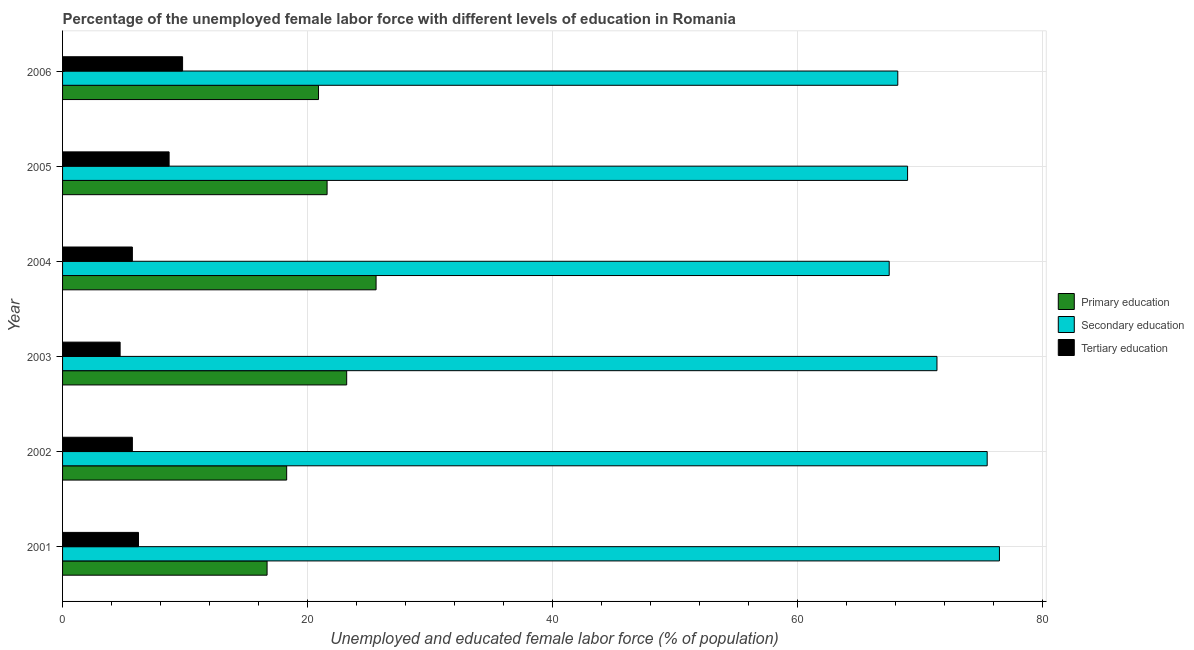How many different coloured bars are there?
Your answer should be compact. 3. How many groups of bars are there?
Your answer should be compact. 6. Are the number of bars per tick equal to the number of legend labels?
Offer a terse response. Yes. Are the number of bars on each tick of the Y-axis equal?
Offer a very short reply. Yes. What is the label of the 2nd group of bars from the top?
Provide a succinct answer. 2005. In how many cases, is the number of bars for a given year not equal to the number of legend labels?
Your response must be concise. 0. What is the percentage of female labor force who received tertiary education in 2005?
Offer a very short reply. 8.7. Across all years, what is the maximum percentage of female labor force who received secondary education?
Your answer should be very brief. 76.5. Across all years, what is the minimum percentage of female labor force who received primary education?
Your answer should be very brief. 16.7. In which year was the percentage of female labor force who received secondary education maximum?
Provide a short and direct response. 2001. What is the total percentage of female labor force who received tertiary education in the graph?
Ensure brevity in your answer.  40.8. What is the difference between the percentage of female labor force who received secondary education in 2002 and that in 2004?
Ensure brevity in your answer.  8. What is the difference between the percentage of female labor force who received primary education in 2004 and the percentage of female labor force who received secondary education in 2006?
Your answer should be very brief. -42.6. What is the average percentage of female labor force who received tertiary education per year?
Ensure brevity in your answer.  6.8. In the year 2002, what is the difference between the percentage of female labor force who received primary education and percentage of female labor force who received secondary education?
Give a very brief answer. -57.2. In how many years, is the percentage of female labor force who received secondary education greater than 16 %?
Keep it short and to the point. 6. What is the ratio of the percentage of female labor force who received secondary education in 2004 to that in 2005?
Provide a short and direct response. 0.98. Is the percentage of female labor force who received primary education in 2002 less than that in 2006?
Provide a succinct answer. Yes. What is the difference between the highest and the lowest percentage of female labor force who received primary education?
Offer a very short reply. 8.9. What does the 1st bar from the top in 2003 represents?
Offer a terse response. Tertiary education. What does the 3rd bar from the bottom in 2004 represents?
Your answer should be compact. Tertiary education. How many years are there in the graph?
Offer a very short reply. 6. Where does the legend appear in the graph?
Ensure brevity in your answer.  Center right. What is the title of the graph?
Offer a terse response. Percentage of the unemployed female labor force with different levels of education in Romania. Does "Negligence towards kids" appear as one of the legend labels in the graph?
Your response must be concise. No. What is the label or title of the X-axis?
Give a very brief answer. Unemployed and educated female labor force (% of population). What is the label or title of the Y-axis?
Your response must be concise. Year. What is the Unemployed and educated female labor force (% of population) in Primary education in 2001?
Provide a short and direct response. 16.7. What is the Unemployed and educated female labor force (% of population) of Secondary education in 2001?
Make the answer very short. 76.5. What is the Unemployed and educated female labor force (% of population) in Tertiary education in 2001?
Provide a short and direct response. 6.2. What is the Unemployed and educated female labor force (% of population) of Primary education in 2002?
Your answer should be compact. 18.3. What is the Unemployed and educated female labor force (% of population) in Secondary education in 2002?
Keep it short and to the point. 75.5. What is the Unemployed and educated female labor force (% of population) of Tertiary education in 2002?
Ensure brevity in your answer.  5.7. What is the Unemployed and educated female labor force (% of population) in Primary education in 2003?
Provide a succinct answer. 23.2. What is the Unemployed and educated female labor force (% of population) in Secondary education in 2003?
Make the answer very short. 71.4. What is the Unemployed and educated female labor force (% of population) of Tertiary education in 2003?
Offer a very short reply. 4.7. What is the Unemployed and educated female labor force (% of population) of Primary education in 2004?
Your response must be concise. 25.6. What is the Unemployed and educated female labor force (% of population) of Secondary education in 2004?
Ensure brevity in your answer.  67.5. What is the Unemployed and educated female labor force (% of population) in Tertiary education in 2004?
Provide a succinct answer. 5.7. What is the Unemployed and educated female labor force (% of population) of Primary education in 2005?
Provide a short and direct response. 21.6. What is the Unemployed and educated female labor force (% of population) of Secondary education in 2005?
Give a very brief answer. 69. What is the Unemployed and educated female labor force (% of population) of Tertiary education in 2005?
Your response must be concise. 8.7. What is the Unemployed and educated female labor force (% of population) in Primary education in 2006?
Provide a short and direct response. 20.9. What is the Unemployed and educated female labor force (% of population) of Secondary education in 2006?
Offer a very short reply. 68.2. What is the Unemployed and educated female labor force (% of population) in Tertiary education in 2006?
Make the answer very short. 9.8. Across all years, what is the maximum Unemployed and educated female labor force (% of population) in Primary education?
Provide a succinct answer. 25.6. Across all years, what is the maximum Unemployed and educated female labor force (% of population) of Secondary education?
Offer a very short reply. 76.5. Across all years, what is the maximum Unemployed and educated female labor force (% of population) of Tertiary education?
Give a very brief answer. 9.8. Across all years, what is the minimum Unemployed and educated female labor force (% of population) in Primary education?
Offer a terse response. 16.7. Across all years, what is the minimum Unemployed and educated female labor force (% of population) of Secondary education?
Provide a succinct answer. 67.5. Across all years, what is the minimum Unemployed and educated female labor force (% of population) in Tertiary education?
Provide a succinct answer. 4.7. What is the total Unemployed and educated female labor force (% of population) of Primary education in the graph?
Keep it short and to the point. 126.3. What is the total Unemployed and educated female labor force (% of population) in Secondary education in the graph?
Offer a very short reply. 428.1. What is the total Unemployed and educated female labor force (% of population) in Tertiary education in the graph?
Offer a terse response. 40.8. What is the difference between the Unemployed and educated female labor force (% of population) in Secondary education in 2001 and that in 2002?
Ensure brevity in your answer.  1. What is the difference between the Unemployed and educated female labor force (% of population) in Tertiary education in 2001 and that in 2002?
Ensure brevity in your answer.  0.5. What is the difference between the Unemployed and educated female labor force (% of population) of Primary education in 2001 and that in 2003?
Give a very brief answer. -6.5. What is the difference between the Unemployed and educated female labor force (% of population) in Secondary education in 2001 and that in 2003?
Offer a terse response. 5.1. What is the difference between the Unemployed and educated female labor force (% of population) in Primary education in 2001 and that in 2004?
Give a very brief answer. -8.9. What is the difference between the Unemployed and educated female labor force (% of population) in Primary education in 2001 and that in 2006?
Your answer should be very brief. -4.2. What is the difference between the Unemployed and educated female labor force (% of population) in Secondary education in 2001 and that in 2006?
Offer a terse response. 8.3. What is the difference between the Unemployed and educated female labor force (% of population) of Primary education in 2002 and that in 2003?
Your response must be concise. -4.9. What is the difference between the Unemployed and educated female labor force (% of population) of Secondary education in 2002 and that in 2003?
Make the answer very short. 4.1. What is the difference between the Unemployed and educated female labor force (% of population) of Primary education in 2002 and that in 2004?
Ensure brevity in your answer.  -7.3. What is the difference between the Unemployed and educated female labor force (% of population) of Secondary education in 2002 and that in 2005?
Give a very brief answer. 6.5. What is the difference between the Unemployed and educated female labor force (% of population) of Secondary education in 2002 and that in 2006?
Offer a terse response. 7.3. What is the difference between the Unemployed and educated female labor force (% of population) of Tertiary education in 2002 and that in 2006?
Make the answer very short. -4.1. What is the difference between the Unemployed and educated female labor force (% of population) in Primary education in 2003 and that in 2004?
Your answer should be very brief. -2.4. What is the difference between the Unemployed and educated female labor force (% of population) in Primary education in 2003 and that in 2005?
Offer a very short reply. 1.6. What is the difference between the Unemployed and educated female labor force (% of population) of Primary education in 2003 and that in 2006?
Provide a succinct answer. 2.3. What is the difference between the Unemployed and educated female labor force (% of population) of Secondary education in 2004 and that in 2006?
Your answer should be very brief. -0.7. What is the difference between the Unemployed and educated female labor force (% of population) of Tertiary education in 2004 and that in 2006?
Make the answer very short. -4.1. What is the difference between the Unemployed and educated female labor force (% of population) in Tertiary education in 2005 and that in 2006?
Provide a succinct answer. -1.1. What is the difference between the Unemployed and educated female labor force (% of population) in Primary education in 2001 and the Unemployed and educated female labor force (% of population) in Secondary education in 2002?
Ensure brevity in your answer.  -58.8. What is the difference between the Unemployed and educated female labor force (% of population) in Primary education in 2001 and the Unemployed and educated female labor force (% of population) in Tertiary education in 2002?
Ensure brevity in your answer.  11. What is the difference between the Unemployed and educated female labor force (% of population) of Secondary education in 2001 and the Unemployed and educated female labor force (% of population) of Tertiary education in 2002?
Give a very brief answer. 70.8. What is the difference between the Unemployed and educated female labor force (% of population) of Primary education in 2001 and the Unemployed and educated female labor force (% of population) of Secondary education in 2003?
Provide a succinct answer. -54.7. What is the difference between the Unemployed and educated female labor force (% of population) in Primary education in 2001 and the Unemployed and educated female labor force (% of population) in Tertiary education in 2003?
Your answer should be very brief. 12. What is the difference between the Unemployed and educated female labor force (% of population) of Secondary education in 2001 and the Unemployed and educated female labor force (% of population) of Tertiary education in 2003?
Provide a short and direct response. 71.8. What is the difference between the Unemployed and educated female labor force (% of population) of Primary education in 2001 and the Unemployed and educated female labor force (% of population) of Secondary education in 2004?
Make the answer very short. -50.8. What is the difference between the Unemployed and educated female labor force (% of population) in Secondary education in 2001 and the Unemployed and educated female labor force (% of population) in Tertiary education in 2004?
Your answer should be very brief. 70.8. What is the difference between the Unemployed and educated female labor force (% of population) of Primary education in 2001 and the Unemployed and educated female labor force (% of population) of Secondary education in 2005?
Provide a succinct answer. -52.3. What is the difference between the Unemployed and educated female labor force (% of population) of Primary education in 2001 and the Unemployed and educated female labor force (% of population) of Tertiary education in 2005?
Your answer should be compact. 8. What is the difference between the Unemployed and educated female labor force (% of population) in Secondary education in 2001 and the Unemployed and educated female labor force (% of population) in Tertiary education in 2005?
Make the answer very short. 67.8. What is the difference between the Unemployed and educated female labor force (% of population) in Primary education in 2001 and the Unemployed and educated female labor force (% of population) in Secondary education in 2006?
Your response must be concise. -51.5. What is the difference between the Unemployed and educated female labor force (% of population) in Primary education in 2001 and the Unemployed and educated female labor force (% of population) in Tertiary education in 2006?
Your answer should be compact. 6.9. What is the difference between the Unemployed and educated female labor force (% of population) in Secondary education in 2001 and the Unemployed and educated female labor force (% of population) in Tertiary education in 2006?
Make the answer very short. 66.7. What is the difference between the Unemployed and educated female labor force (% of population) of Primary education in 2002 and the Unemployed and educated female labor force (% of population) of Secondary education in 2003?
Make the answer very short. -53.1. What is the difference between the Unemployed and educated female labor force (% of population) of Primary education in 2002 and the Unemployed and educated female labor force (% of population) of Tertiary education in 2003?
Your answer should be very brief. 13.6. What is the difference between the Unemployed and educated female labor force (% of population) of Secondary education in 2002 and the Unemployed and educated female labor force (% of population) of Tertiary education in 2003?
Make the answer very short. 70.8. What is the difference between the Unemployed and educated female labor force (% of population) in Primary education in 2002 and the Unemployed and educated female labor force (% of population) in Secondary education in 2004?
Give a very brief answer. -49.2. What is the difference between the Unemployed and educated female labor force (% of population) of Secondary education in 2002 and the Unemployed and educated female labor force (% of population) of Tertiary education in 2004?
Ensure brevity in your answer.  69.8. What is the difference between the Unemployed and educated female labor force (% of population) of Primary education in 2002 and the Unemployed and educated female labor force (% of population) of Secondary education in 2005?
Your answer should be very brief. -50.7. What is the difference between the Unemployed and educated female labor force (% of population) of Primary education in 2002 and the Unemployed and educated female labor force (% of population) of Tertiary education in 2005?
Offer a terse response. 9.6. What is the difference between the Unemployed and educated female labor force (% of population) of Secondary education in 2002 and the Unemployed and educated female labor force (% of population) of Tertiary education in 2005?
Ensure brevity in your answer.  66.8. What is the difference between the Unemployed and educated female labor force (% of population) in Primary education in 2002 and the Unemployed and educated female labor force (% of population) in Secondary education in 2006?
Offer a terse response. -49.9. What is the difference between the Unemployed and educated female labor force (% of population) of Secondary education in 2002 and the Unemployed and educated female labor force (% of population) of Tertiary education in 2006?
Ensure brevity in your answer.  65.7. What is the difference between the Unemployed and educated female labor force (% of population) in Primary education in 2003 and the Unemployed and educated female labor force (% of population) in Secondary education in 2004?
Provide a succinct answer. -44.3. What is the difference between the Unemployed and educated female labor force (% of population) of Primary education in 2003 and the Unemployed and educated female labor force (% of population) of Tertiary education in 2004?
Make the answer very short. 17.5. What is the difference between the Unemployed and educated female labor force (% of population) in Secondary education in 2003 and the Unemployed and educated female labor force (% of population) in Tertiary education in 2004?
Offer a terse response. 65.7. What is the difference between the Unemployed and educated female labor force (% of population) in Primary education in 2003 and the Unemployed and educated female labor force (% of population) in Secondary education in 2005?
Ensure brevity in your answer.  -45.8. What is the difference between the Unemployed and educated female labor force (% of population) of Secondary education in 2003 and the Unemployed and educated female labor force (% of population) of Tertiary education in 2005?
Your answer should be compact. 62.7. What is the difference between the Unemployed and educated female labor force (% of population) in Primary education in 2003 and the Unemployed and educated female labor force (% of population) in Secondary education in 2006?
Offer a terse response. -45. What is the difference between the Unemployed and educated female labor force (% of population) of Primary education in 2003 and the Unemployed and educated female labor force (% of population) of Tertiary education in 2006?
Offer a very short reply. 13.4. What is the difference between the Unemployed and educated female labor force (% of population) of Secondary education in 2003 and the Unemployed and educated female labor force (% of population) of Tertiary education in 2006?
Your answer should be compact. 61.6. What is the difference between the Unemployed and educated female labor force (% of population) of Primary education in 2004 and the Unemployed and educated female labor force (% of population) of Secondary education in 2005?
Keep it short and to the point. -43.4. What is the difference between the Unemployed and educated female labor force (% of population) in Secondary education in 2004 and the Unemployed and educated female labor force (% of population) in Tertiary education in 2005?
Ensure brevity in your answer.  58.8. What is the difference between the Unemployed and educated female labor force (% of population) of Primary education in 2004 and the Unemployed and educated female labor force (% of population) of Secondary education in 2006?
Ensure brevity in your answer.  -42.6. What is the difference between the Unemployed and educated female labor force (% of population) of Primary education in 2004 and the Unemployed and educated female labor force (% of population) of Tertiary education in 2006?
Keep it short and to the point. 15.8. What is the difference between the Unemployed and educated female labor force (% of population) in Secondary education in 2004 and the Unemployed and educated female labor force (% of population) in Tertiary education in 2006?
Your answer should be compact. 57.7. What is the difference between the Unemployed and educated female labor force (% of population) in Primary education in 2005 and the Unemployed and educated female labor force (% of population) in Secondary education in 2006?
Keep it short and to the point. -46.6. What is the difference between the Unemployed and educated female labor force (% of population) in Secondary education in 2005 and the Unemployed and educated female labor force (% of population) in Tertiary education in 2006?
Keep it short and to the point. 59.2. What is the average Unemployed and educated female labor force (% of population) of Primary education per year?
Keep it short and to the point. 21.05. What is the average Unemployed and educated female labor force (% of population) in Secondary education per year?
Your answer should be very brief. 71.35. What is the average Unemployed and educated female labor force (% of population) in Tertiary education per year?
Provide a succinct answer. 6.8. In the year 2001, what is the difference between the Unemployed and educated female labor force (% of population) in Primary education and Unemployed and educated female labor force (% of population) in Secondary education?
Give a very brief answer. -59.8. In the year 2001, what is the difference between the Unemployed and educated female labor force (% of population) of Primary education and Unemployed and educated female labor force (% of population) of Tertiary education?
Make the answer very short. 10.5. In the year 2001, what is the difference between the Unemployed and educated female labor force (% of population) of Secondary education and Unemployed and educated female labor force (% of population) of Tertiary education?
Provide a short and direct response. 70.3. In the year 2002, what is the difference between the Unemployed and educated female labor force (% of population) of Primary education and Unemployed and educated female labor force (% of population) of Secondary education?
Offer a terse response. -57.2. In the year 2002, what is the difference between the Unemployed and educated female labor force (% of population) in Secondary education and Unemployed and educated female labor force (% of population) in Tertiary education?
Your response must be concise. 69.8. In the year 2003, what is the difference between the Unemployed and educated female labor force (% of population) in Primary education and Unemployed and educated female labor force (% of population) in Secondary education?
Give a very brief answer. -48.2. In the year 2003, what is the difference between the Unemployed and educated female labor force (% of population) of Secondary education and Unemployed and educated female labor force (% of population) of Tertiary education?
Make the answer very short. 66.7. In the year 2004, what is the difference between the Unemployed and educated female labor force (% of population) in Primary education and Unemployed and educated female labor force (% of population) in Secondary education?
Your response must be concise. -41.9. In the year 2004, what is the difference between the Unemployed and educated female labor force (% of population) of Primary education and Unemployed and educated female labor force (% of population) of Tertiary education?
Keep it short and to the point. 19.9. In the year 2004, what is the difference between the Unemployed and educated female labor force (% of population) of Secondary education and Unemployed and educated female labor force (% of population) of Tertiary education?
Your answer should be compact. 61.8. In the year 2005, what is the difference between the Unemployed and educated female labor force (% of population) in Primary education and Unemployed and educated female labor force (% of population) in Secondary education?
Provide a short and direct response. -47.4. In the year 2005, what is the difference between the Unemployed and educated female labor force (% of population) of Secondary education and Unemployed and educated female labor force (% of population) of Tertiary education?
Ensure brevity in your answer.  60.3. In the year 2006, what is the difference between the Unemployed and educated female labor force (% of population) of Primary education and Unemployed and educated female labor force (% of population) of Secondary education?
Give a very brief answer. -47.3. In the year 2006, what is the difference between the Unemployed and educated female labor force (% of population) of Primary education and Unemployed and educated female labor force (% of population) of Tertiary education?
Your response must be concise. 11.1. In the year 2006, what is the difference between the Unemployed and educated female labor force (% of population) in Secondary education and Unemployed and educated female labor force (% of population) in Tertiary education?
Your response must be concise. 58.4. What is the ratio of the Unemployed and educated female labor force (% of population) of Primary education in 2001 to that in 2002?
Your answer should be very brief. 0.91. What is the ratio of the Unemployed and educated female labor force (% of population) of Secondary education in 2001 to that in 2002?
Your answer should be very brief. 1.01. What is the ratio of the Unemployed and educated female labor force (% of population) of Tertiary education in 2001 to that in 2002?
Give a very brief answer. 1.09. What is the ratio of the Unemployed and educated female labor force (% of population) in Primary education in 2001 to that in 2003?
Your answer should be very brief. 0.72. What is the ratio of the Unemployed and educated female labor force (% of population) in Secondary education in 2001 to that in 2003?
Offer a terse response. 1.07. What is the ratio of the Unemployed and educated female labor force (% of population) in Tertiary education in 2001 to that in 2003?
Offer a terse response. 1.32. What is the ratio of the Unemployed and educated female labor force (% of population) in Primary education in 2001 to that in 2004?
Give a very brief answer. 0.65. What is the ratio of the Unemployed and educated female labor force (% of population) in Secondary education in 2001 to that in 2004?
Provide a succinct answer. 1.13. What is the ratio of the Unemployed and educated female labor force (% of population) in Tertiary education in 2001 to that in 2004?
Offer a terse response. 1.09. What is the ratio of the Unemployed and educated female labor force (% of population) of Primary education in 2001 to that in 2005?
Offer a terse response. 0.77. What is the ratio of the Unemployed and educated female labor force (% of population) in Secondary education in 2001 to that in 2005?
Keep it short and to the point. 1.11. What is the ratio of the Unemployed and educated female labor force (% of population) of Tertiary education in 2001 to that in 2005?
Ensure brevity in your answer.  0.71. What is the ratio of the Unemployed and educated female labor force (% of population) of Primary education in 2001 to that in 2006?
Provide a short and direct response. 0.8. What is the ratio of the Unemployed and educated female labor force (% of population) of Secondary education in 2001 to that in 2006?
Provide a succinct answer. 1.12. What is the ratio of the Unemployed and educated female labor force (% of population) of Tertiary education in 2001 to that in 2006?
Your answer should be very brief. 0.63. What is the ratio of the Unemployed and educated female labor force (% of population) in Primary education in 2002 to that in 2003?
Offer a terse response. 0.79. What is the ratio of the Unemployed and educated female labor force (% of population) in Secondary education in 2002 to that in 2003?
Your response must be concise. 1.06. What is the ratio of the Unemployed and educated female labor force (% of population) in Tertiary education in 2002 to that in 2003?
Ensure brevity in your answer.  1.21. What is the ratio of the Unemployed and educated female labor force (% of population) in Primary education in 2002 to that in 2004?
Ensure brevity in your answer.  0.71. What is the ratio of the Unemployed and educated female labor force (% of population) in Secondary education in 2002 to that in 2004?
Keep it short and to the point. 1.12. What is the ratio of the Unemployed and educated female labor force (% of population) in Primary education in 2002 to that in 2005?
Your answer should be very brief. 0.85. What is the ratio of the Unemployed and educated female labor force (% of population) in Secondary education in 2002 to that in 2005?
Provide a short and direct response. 1.09. What is the ratio of the Unemployed and educated female labor force (% of population) in Tertiary education in 2002 to that in 2005?
Your answer should be very brief. 0.66. What is the ratio of the Unemployed and educated female labor force (% of population) of Primary education in 2002 to that in 2006?
Give a very brief answer. 0.88. What is the ratio of the Unemployed and educated female labor force (% of population) of Secondary education in 2002 to that in 2006?
Ensure brevity in your answer.  1.11. What is the ratio of the Unemployed and educated female labor force (% of population) in Tertiary education in 2002 to that in 2006?
Make the answer very short. 0.58. What is the ratio of the Unemployed and educated female labor force (% of population) in Primary education in 2003 to that in 2004?
Provide a succinct answer. 0.91. What is the ratio of the Unemployed and educated female labor force (% of population) in Secondary education in 2003 to that in 2004?
Make the answer very short. 1.06. What is the ratio of the Unemployed and educated female labor force (% of population) of Tertiary education in 2003 to that in 2004?
Provide a succinct answer. 0.82. What is the ratio of the Unemployed and educated female labor force (% of population) in Primary education in 2003 to that in 2005?
Your response must be concise. 1.07. What is the ratio of the Unemployed and educated female labor force (% of population) in Secondary education in 2003 to that in 2005?
Your answer should be compact. 1.03. What is the ratio of the Unemployed and educated female labor force (% of population) in Tertiary education in 2003 to that in 2005?
Offer a terse response. 0.54. What is the ratio of the Unemployed and educated female labor force (% of population) in Primary education in 2003 to that in 2006?
Your answer should be very brief. 1.11. What is the ratio of the Unemployed and educated female labor force (% of population) of Secondary education in 2003 to that in 2006?
Keep it short and to the point. 1.05. What is the ratio of the Unemployed and educated female labor force (% of population) of Tertiary education in 2003 to that in 2006?
Make the answer very short. 0.48. What is the ratio of the Unemployed and educated female labor force (% of population) in Primary education in 2004 to that in 2005?
Your response must be concise. 1.19. What is the ratio of the Unemployed and educated female labor force (% of population) of Secondary education in 2004 to that in 2005?
Give a very brief answer. 0.98. What is the ratio of the Unemployed and educated female labor force (% of population) in Tertiary education in 2004 to that in 2005?
Give a very brief answer. 0.66. What is the ratio of the Unemployed and educated female labor force (% of population) of Primary education in 2004 to that in 2006?
Keep it short and to the point. 1.22. What is the ratio of the Unemployed and educated female labor force (% of population) in Tertiary education in 2004 to that in 2006?
Offer a terse response. 0.58. What is the ratio of the Unemployed and educated female labor force (% of population) of Primary education in 2005 to that in 2006?
Give a very brief answer. 1.03. What is the ratio of the Unemployed and educated female labor force (% of population) in Secondary education in 2005 to that in 2006?
Offer a very short reply. 1.01. What is the ratio of the Unemployed and educated female labor force (% of population) in Tertiary education in 2005 to that in 2006?
Make the answer very short. 0.89. What is the difference between the highest and the second highest Unemployed and educated female labor force (% of population) in Primary education?
Ensure brevity in your answer.  2.4. What is the difference between the highest and the second highest Unemployed and educated female labor force (% of population) of Secondary education?
Offer a terse response. 1. What is the difference between the highest and the lowest Unemployed and educated female labor force (% of population) of Secondary education?
Your answer should be compact. 9. 